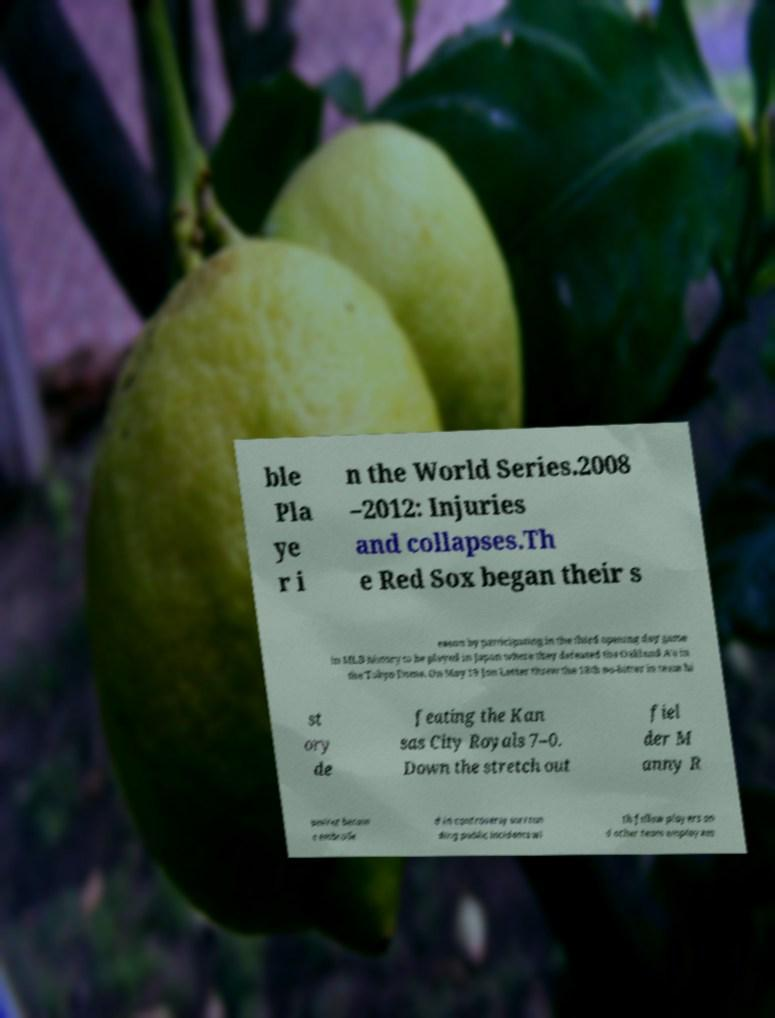Please read and relay the text visible in this image. What does it say? ble Pla ye r i n the World Series.2008 –2012: Injuries and collapses.Th e Red Sox began their s eason by participating in the third opening day game in MLB history to be played in Japan where they defeated the Oakland A's in the Tokyo Dome. On May 19 Jon Lester threw the 18th no-hitter in team hi st ory de feating the Kan sas City Royals 7–0. Down the stretch out fiel der M anny R amirez becam e embroile d in controversy surroun ding public incidents wi th fellow players an d other team employees 